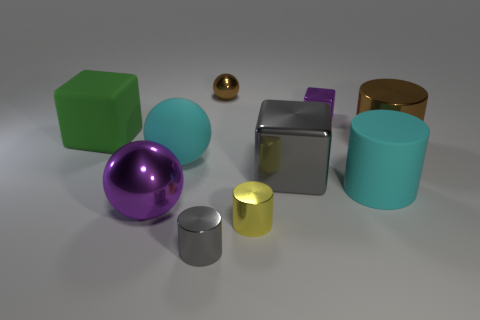Subtract 1 balls. How many balls are left? 2 Subtract all large balls. How many balls are left? 1 Subtract all cyan cylinders. How many cylinders are left? 3 Subtract all blue cylinders. Subtract all yellow cubes. How many cylinders are left? 4 Subtract all blocks. How many objects are left? 7 Subtract all big green metallic things. Subtract all big cyan matte spheres. How many objects are left? 9 Add 8 tiny purple metal objects. How many tiny purple metal objects are left? 9 Add 1 gray cubes. How many gray cubes exist? 2 Subtract 0 blue blocks. How many objects are left? 10 